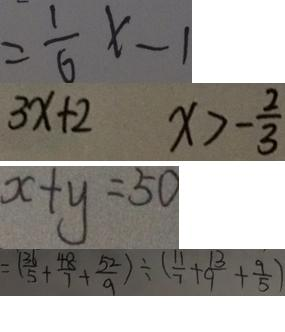<formula> <loc_0><loc_0><loc_500><loc_500>= \frac { 1 } { 6 } x - 1 
 3 x + 2 x > - \frac { 2 } { 3 } 
 x + y = 5 0 
 = ( \frac { 3 1 } { 5 } + \frac { 4 8 } { 7 } + \frac { 5 2 } { 9 } ) \div ( \frac { 1 1 } { 7 } + \frac { 1 3 } { 9 } + \frac { 9 } { 5 } )</formula> 